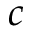Convert formula to latex. <formula><loc_0><loc_0><loc_500><loc_500>c</formula> 